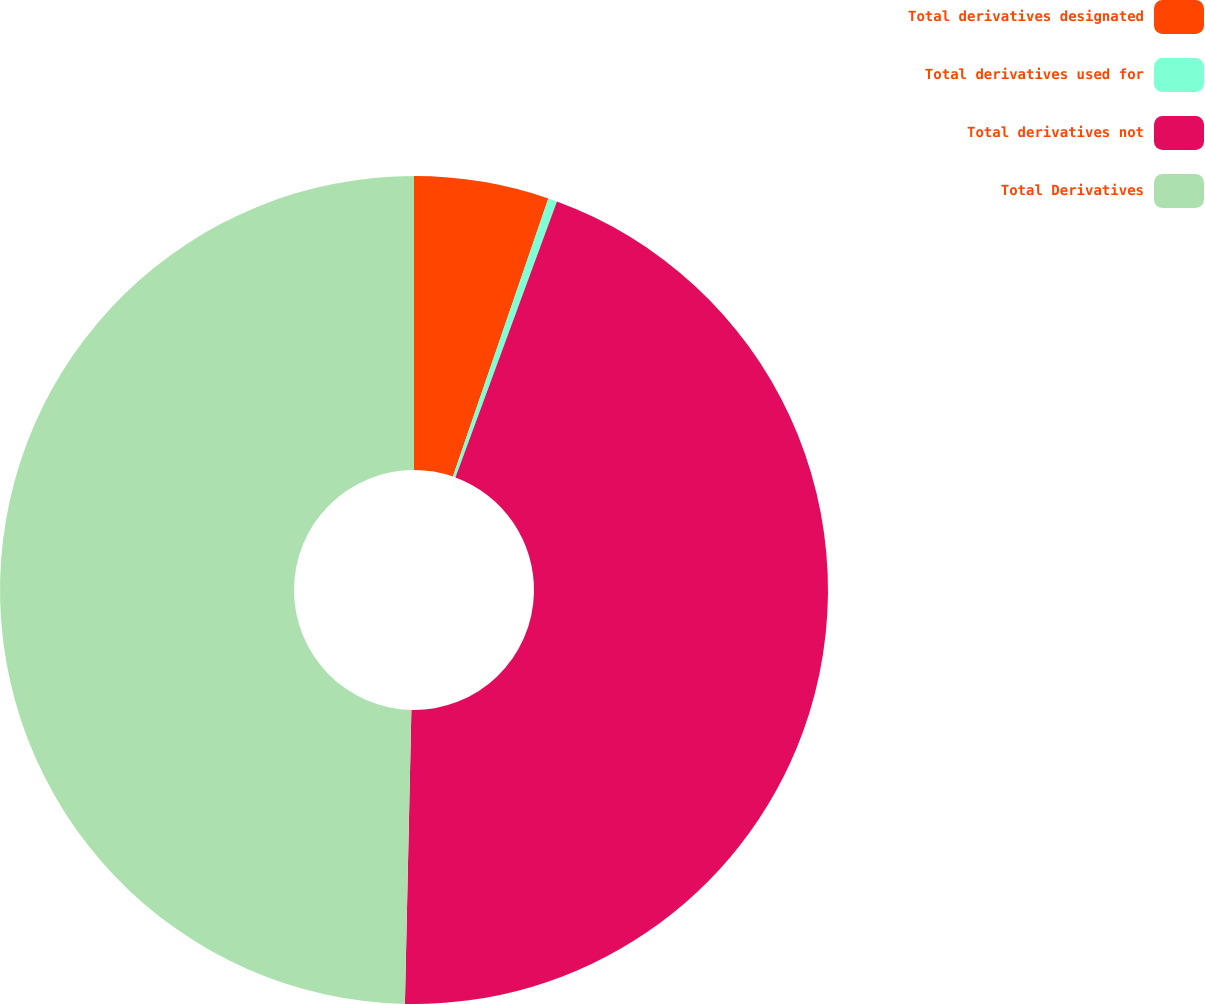<chart> <loc_0><loc_0><loc_500><loc_500><pie_chart><fcel>Total derivatives designated<fcel>Total derivatives used for<fcel>Total derivatives not<fcel>Total Derivatives<nl><fcel>5.26%<fcel>0.35%<fcel>44.74%<fcel>49.65%<nl></chart> 